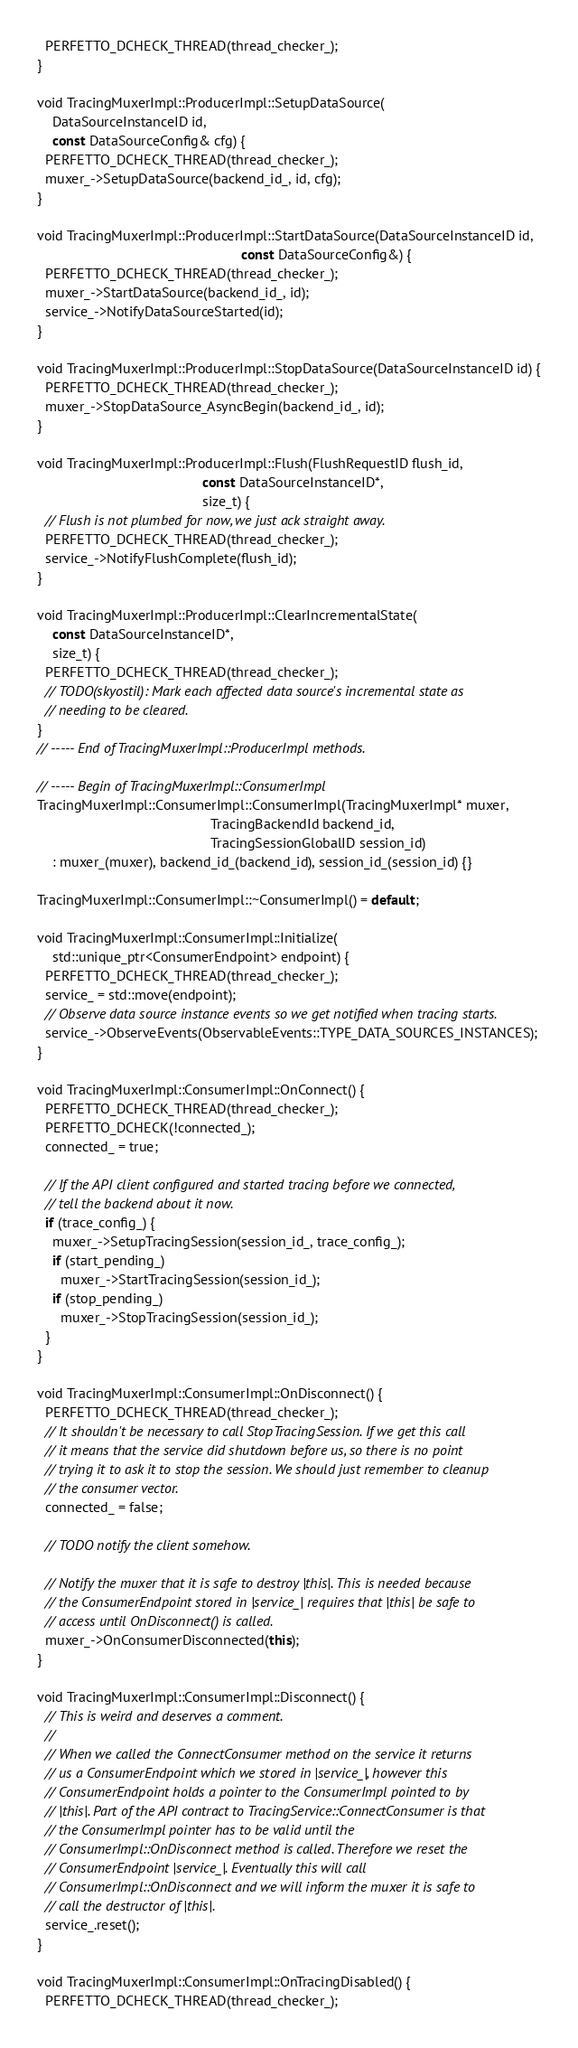Convert code to text. <code><loc_0><loc_0><loc_500><loc_500><_C++_>  PERFETTO_DCHECK_THREAD(thread_checker_);
}

void TracingMuxerImpl::ProducerImpl::SetupDataSource(
    DataSourceInstanceID id,
    const DataSourceConfig& cfg) {
  PERFETTO_DCHECK_THREAD(thread_checker_);
  muxer_->SetupDataSource(backend_id_, id, cfg);
}

void TracingMuxerImpl::ProducerImpl::StartDataSource(DataSourceInstanceID id,
                                                     const DataSourceConfig&) {
  PERFETTO_DCHECK_THREAD(thread_checker_);
  muxer_->StartDataSource(backend_id_, id);
  service_->NotifyDataSourceStarted(id);
}

void TracingMuxerImpl::ProducerImpl::StopDataSource(DataSourceInstanceID id) {
  PERFETTO_DCHECK_THREAD(thread_checker_);
  muxer_->StopDataSource_AsyncBegin(backend_id_, id);
}

void TracingMuxerImpl::ProducerImpl::Flush(FlushRequestID flush_id,
                                           const DataSourceInstanceID*,
                                           size_t) {
  // Flush is not plumbed for now, we just ack straight away.
  PERFETTO_DCHECK_THREAD(thread_checker_);
  service_->NotifyFlushComplete(flush_id);
}

void TracingMuxerImpl::ProducerImpl::ClearIncrementalState(
    const DataSourceInstanceID*,
    size_t) {
  PERFETTO_DCHECK_THREAD(thread_checker_);
  // TODO(skyostil): Mark each affected data source's incremental state as
  // needing to be cleared.
}
// ----- End of TracingMuxerImpl::ProducerImpl methods.

// ----- Begin of TracingMuxerImpl::ConsumerImpl
TracingMuxerImpl::ConsumerImpl::ConsumerImpl(TracingMuxerImpl* muxer,
                                             TracingBackendId backend_id,
                                             TracingSessionGlobalID session_id)
    : muxer_(muxer), backend_id_(backend_id), session_id_(session_id) {}

TracingMuxerImpl::ConsumerImpl::~ConsumerImpl() = default;

void TracingMuxerImpl::ConsumerImpl::Initialize(
    std::unique_ptr<ConsumerEndpoint> endpoint) {
  PERFETTO_DCHECK_THREAD(thread_checker_);
  service_ = std::move(endpoint);
  // Observe data source instance events so we get notified when tracing starts.
  service_->ObserveEvents(ObservableEvents::TYPE_DATA_SOURCES_INSTANCES);
}

void TracingMuxerImpl::ConsumerImpl::OnConnect() {
  PERFETTO_DCHECK_THREAD(thread_checker_);
  PERFETTO_DCHECK(!connected_);
  connected_ = true;

  // If the API client configured and started tracing before we connected,
  // tell the backend about it now.
  if (trace_config_) {
    muxer_->SetupTracingSession(session_id_, trace_config_);
    if (start_pending_)
      muxer_->StartTracingSession(session_id_);
    if (stop_pending_)
      muxer_->StopTracingSession(session_id_);
  }
}

void TracingMuxerImpl::ConsumerImpl::OnDisconnect() {
  PERFETTO_DCHECK_THREAD(thread_checker_);
  // It shouldn't be necessary to call StopTracingSession. If we get this call
  // it means that the service did shutdown before us, so there is no point
  // trying it to ask it to stop the session. We should just remember to cleanup
  // the consumer vector.
  connected_ = false;

  // TODO notify the client somehow.

  // Notify the muxer that it is safe to destroy |this|. This is needed because
  // the ConsumerEndpoint stored in |service_| requires that |this| be safe to
  // access until OnDisconnect() is called.
  muxer_->OnConsumerDisconnected(this);
}

void TracingMuxerImpl::ConsumerImpl::Disconnect() {
  // This is weird and deserves a comment.
  //
  // When we called the ConnectConsumer method on the service it returns
  // us a ConsumerEndpoint which we stored in |service_|, however this
  // ConsumerEndpoint holds a pointer to the ConsumerImpl pointed to by
  // |this|. Part of the API contract to TracingService::ConnectConsumer is that
  // the ConsumerImpl pointer has to be valid until the
  // ConsumerImpl::OnDisconnect method is called. Therefore we reset the
  // ConsumerEndpoint |service_|. Eventually this will call
  // ConsumerImpl::OnDisconnect and we will inform the muxer it is safe to
  // call the destructor of |this|.
  service_.reset();
}

void TracingMuxerImpl::ConsumerImpl::OnTracingDisabled() {
  PERFETTO_DCHECK_THREAD(thread_checker_);</code> 